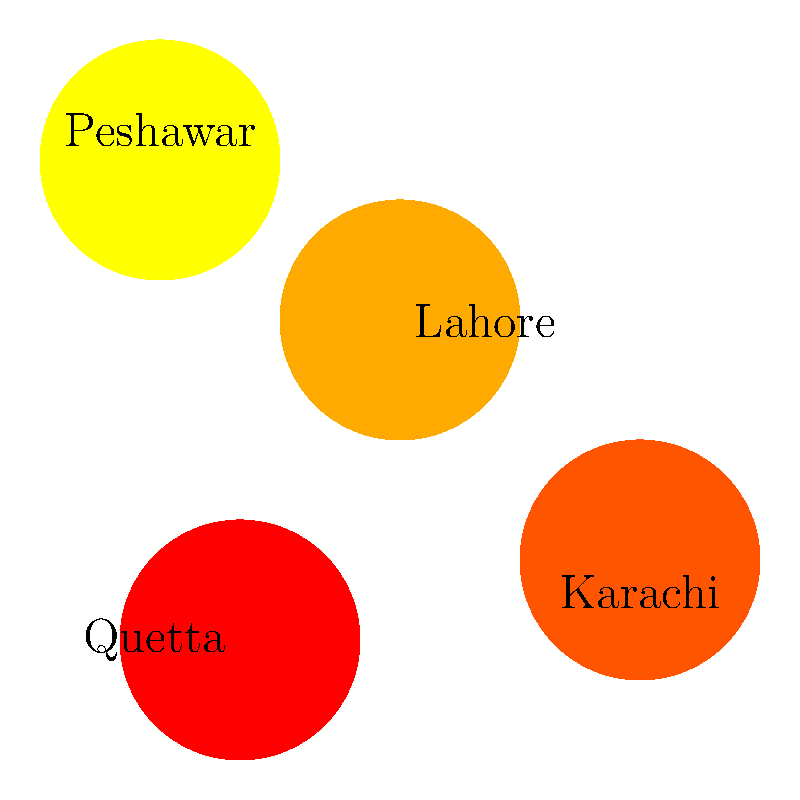Based on the geographic heat map of Islamic movements in Pakistan, which city appears to have the highest intensity of movement activity, and what factors might contribute to this phenomenon? To answer this question, we need to analyze the heat map and consider historical and geographical factors:

1. Observe the heat map: The map shows four main cities in Pakistan with varying intensities of Islamic movement activity.

2. Identify the highest intensity: Peshawar, in the northwest, shows the highest intensity (darkest red).

3. Consider geographical factors:
   - Peshawar is close to the Afghanistan border, a region known for its conservative Islamic traditions.
   - The city is part of the historically significant Khyber Pakhtunkhwa province.

4. Historical context:
   - Peshawar has been a center for Islamic education and scholarship for centuries.
   - The region has been influenced by various Islamic movements, including Deobandi and Tablighi Jamaat.

5. Recent history:
   - The Afghan War and subsequent refugee influx have impacted the religious landscape.
   - The area has seen the rise of more conservative interpretations of Islam.

6. Comparative analysis:
   - Lahore shows the second-highest intensity, likely due to its historical importance and large population.
   - Karachi and Quetta show lower intensities, possibly due to their more diverse populations and different historical contexts.

The high intensity in Peshawar can be attributed to its geographical proximity to Afghanistan, historical significance in Islamic scholarship, and recent geopolitical events affecting the region.
Answer: Peshawar; border proximity, historical significance, and recent geopolitical events. 